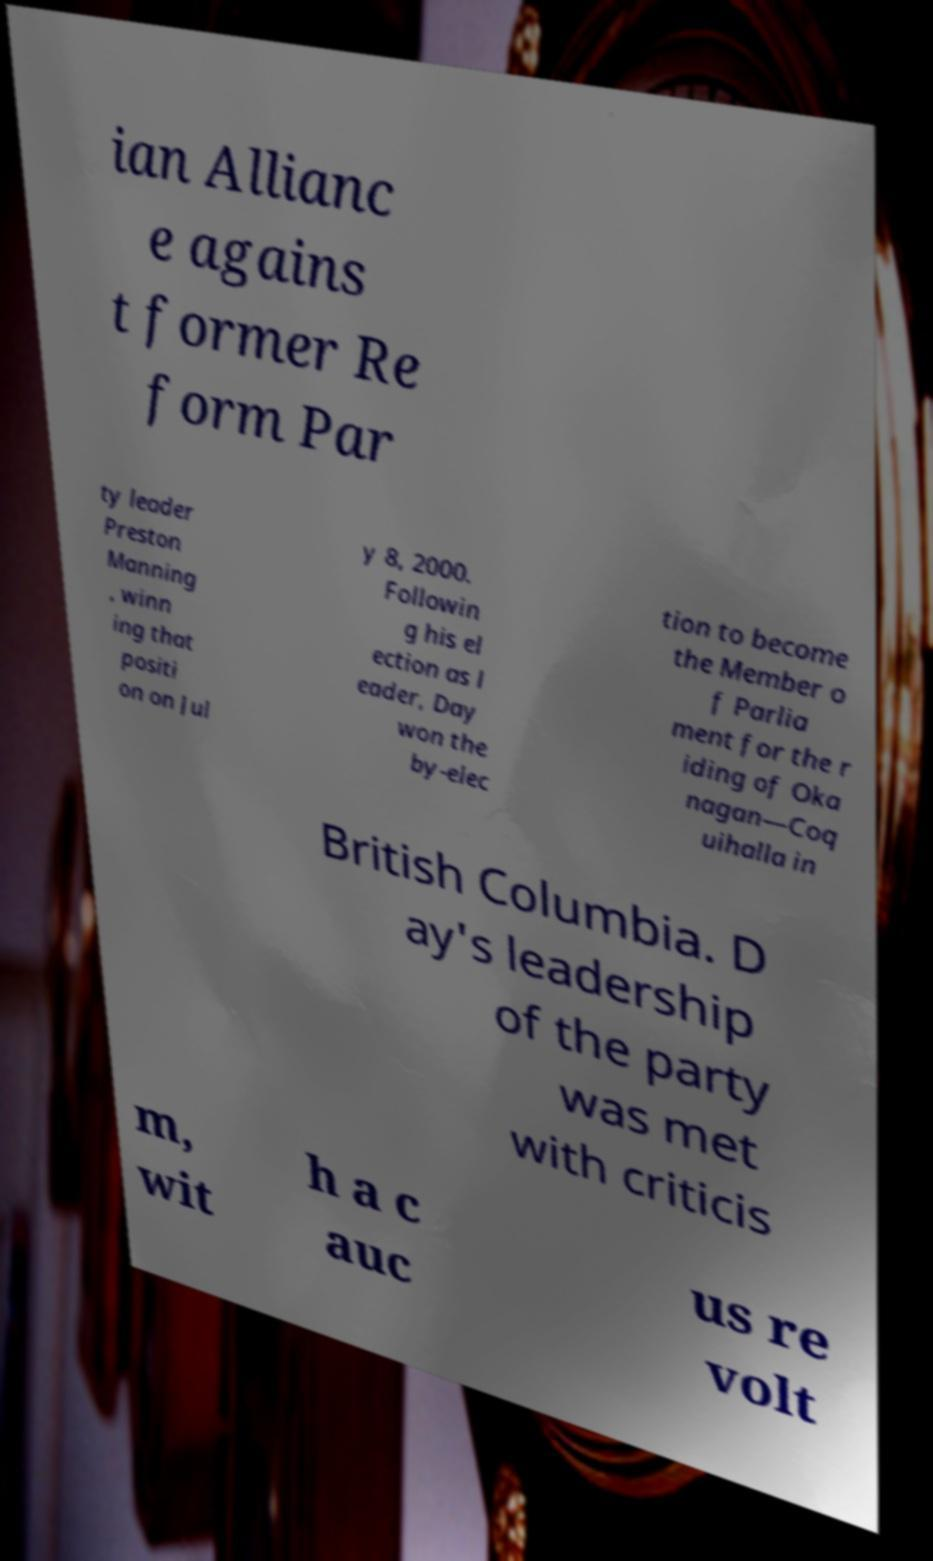Can you accurately transcribe the text from the provided image for me? ian Allianc e agains t former Re form Par ty leader Preston Manning , winn ing that positi on on Jul y 8, 2000. Followin g his el ection as l eader, Day won the by-elec tion to become the Member o f Parlia ment for the r iding of Oka nagan—Coq uihalla in British Columbia. D ay's leadership of the party was met with criticis m, wit h a c auc us re volt 